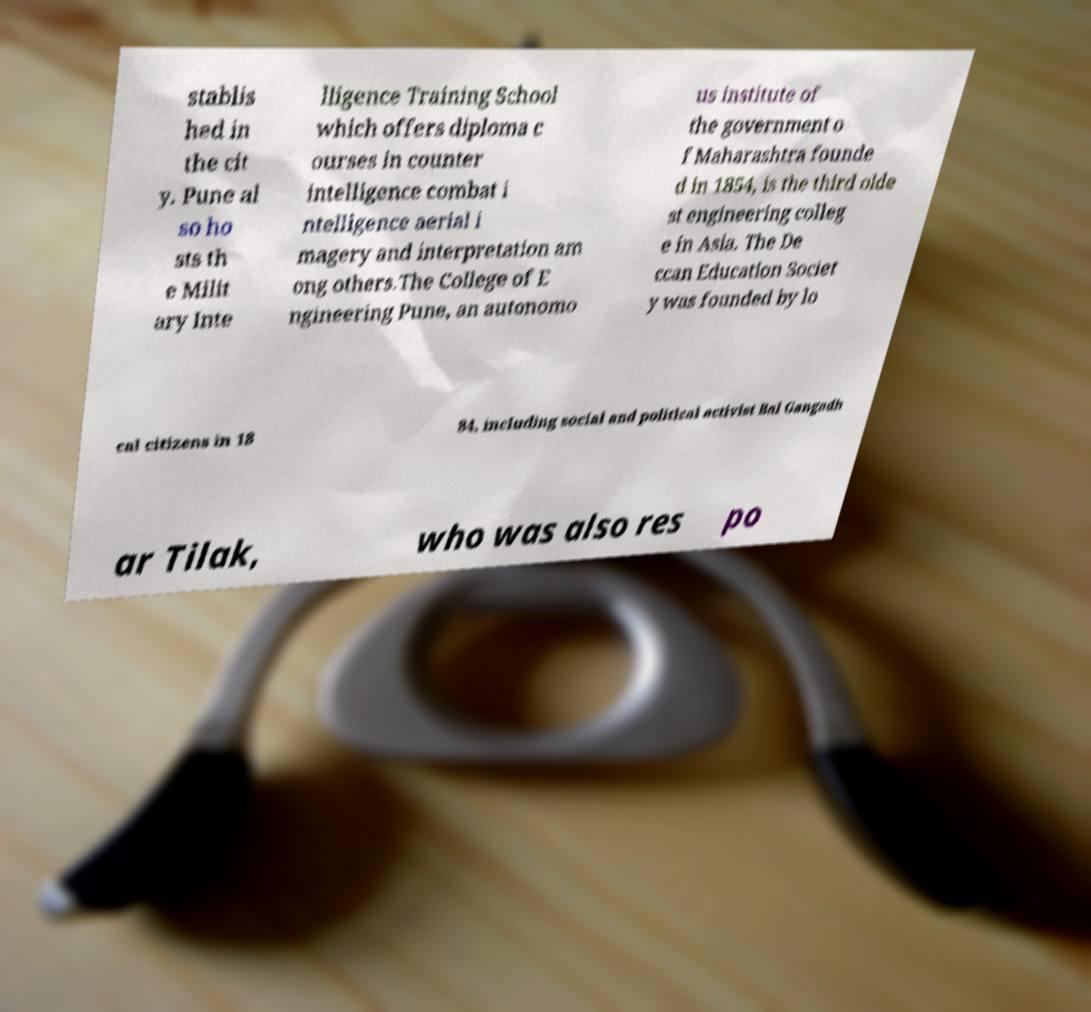Could you assist in decoding the text presented in this image and type it out clearly? stablis hed in the cit y. Pune al so ho sts th e Milit ary Inte lligence Training School which offers diploma c ourses in counter intelligence combat i ntelligence aerial i magery and interpretation am ong others.The College of E ngineering Pune, an autonomo us institute of the government o f Maharashtra founde d in 1854, is the third olde st engineering colleg e in Asia. The De ccan Education Societ y was founded by lo cal citizens in 18 84, including social and political activist Bal Gangadh ar Tilak, who was also res po 